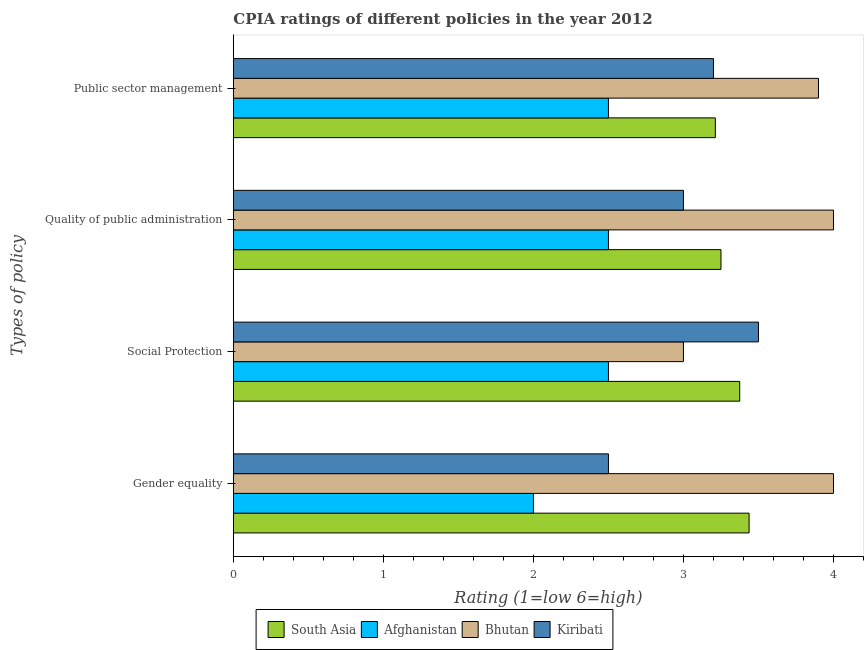How many different coloured bars are there?
Provide a succinct answer. 4. How many groups of bars are there?
Give a very brief answer. 4. Are the number of bars per tick equal to the number of legend labels?
Your answer should be very brief. Yes. Are the number of bars on each tick of the Y-axis equal?
Your response must be concise. Yes. How many bars are there on the 1st tick from the top?
Your answer should be very brief. 4. How many bars are there on the 3rd tick from the bottom?
Offer a very short reply. 4. What is the label of the 3rd group of bars from the top?
Make the answer very short. Social Protection. In which country was the cpia rating of public sector management maximum?
Offer a terse response. Bhutan. In which country was the cpia rating of quality of public administration minimum?
Give a very brief answer. Afghanistan. What is the total cpia rating of public sector management in the graph?
Make the answer very short. 12.81. What is the difference between the cpia rating of quality of public administration in Afghanistan and that in South Asia?
Your response must be concise. -0.75. What is the difference between the cpia rating of public sector management in South Asia and the cpia rating of gender equality in Kiribati?
Provide a short and direct response. 0.71. What is the average cpia rating of quality of public administration per country?
Offer a terse response. 3.19. What is the difference between the cpia rating of public sector management and cpia rating of social protection in South Asia?
Keep it short and to the point. -0.16. In how many countries, is the cpia rating of social protection greater than 2.6 ?
Keep it short and to the point. 3. What is the ratio of the cpia rating of public sector management in Afghanistan to that in South Asia?
Ensure brevity in your answer.  0.78. Is the difference between the cpia rating of social protection in Bhutan and Afghanistan greater than the difference between the cpia rating of quality of public administration in Bhutan and Afghanistan?
Offer a terse response. No. What is the difference between the highest and the second highest cpia rating of public sector management?
Your answer should be very brief. 0.69. What is the difference between the highest and the lowest cpia rating of quality of public administration?
Your answer should be compact. 1.5. Is the sum of the cpia rating of social protection in South Asia and Afghanistan greater than the maximum cpia rating of gender equality across all countries?
Offer a terse response. Yes. What does the 3rd bar from the top in Quality of public administration represents?
Give a very brief answer. Afghanistan. What does the 1st bar from the bottom in Social Protection represents?
Offer a terse response. South Asia. Is it the case that in every country, the sum of the cpia rating of gender equality and cpia rating of social protection is greater than the cpia rating of quality of public administration?
Your answer should be compact. Yes. How many countries are there in the graph?
Offer a terse response. 4. What is the difference between two consecutive major ticks on the X-axis?
Give a very brief answer. 1. Are the values on the major ticks of X-axis written in scientific E-notation?
Make the answer very short. No. Does the graph contain any zero values?
Give a very brief answer. No. How are the legend labels stacked?
Keep it short and to the point. Horizontal. What is the title of the graph?
Your answer should be very brief. CPIA ratings of different policies in the year 2012. What is the label or title of the X-axis?
Keep it short and to the point. Rating (1=low 6=high). What is the label or title of the Y-axis?
Ensure brevity in your answer.  Types of policy. What is the Rating (1=low 6=high) in South Asia in Gender equality?
Your answer should be compact. 3.44. What is the Rating (1=low 6=high) in Afghanistan in Gender equality?
Make the answer very short. 2. What is the Rating (1=low 6=high) in South Asia in Social Protection?
Offer a terse response. 3.38. What is the Rating (1=low 6=high) in Afghanistan in Social Protection?
Make the answer very short. 2.5. What is the Rating (1=low 6=high) of Bhutan in Social Protection?
Your response must be concise. 3. What is the Rating (1=low 6=high) of South Asia in Quality of public administration?
Keep it short and to the point. 3.25. What is the Rating (1=low 6=high) in Bhutan in Quality of public administration?
Your answer should be compact. 4. What is the Rating (1=low 6=high) of South Asia in Public sector management?
Your answer should be compact. 3.21. What is the Rating (1=low 6=high) in Kiribati in Public sector management?
Keep it short and to the point. 3.2. Across all Types of policy, what is the maximum Rating (1=low 6=high) of South Asia?
Your response must be concise. 3.44. Across all Types of policy, what is the maximum Rating (1=low 6=high) in Kiribati?
Give a very brief answer. 3.5. Across all Types of policy, what is the minimum Rating (1=low 6=high) in South Asia?
Make the answer very short. 3.21. What is the total Rating (1=low 6=high) in South Asia in the graph?
Provide a succinct answer. 13.28. What is the total Rating (1=low 6=high) of Kiribati in the graph?
Your answer should be very brief. 12.2. What is the difference between the Rating (1=low 6=high) in South Asia in Gender equality and that in Social Protection?
Offer a terse response. 0.06. What is the difference between the Rating (1=low 6=high) in Afghanistan in Gender equality and that in Social Protection?
Your response must be concise. -0.5. What is the difference between the Rating (1=low 6=high) in Bhutan in Gender equality and that in Social Protection?
Provide a succinct answer. 1. What is the difference between the Rating (1=low 6=high) in South Asia in Gender equality and that in Quality of public administration?
Your answer should be compact. 0.19. What is the difference between the Rating (1=low 6=high) of South Asia in Gender equality and that in Public sector management?
Keep it short and to the point. 0.23. What is the difference between the Rating (1=low 6=high) of South Asia in Social Protection and that in Quality of public administration?
Ensure brevity in your answer.  0.12. What is the difference between the Rating (1=low 6=high) of South Asia in Social Protection and that in Public sector management?
Provide a short and direct response. 0.16. What is the difference between the Rating (1=low 6=high) of Afghanistan in Social Protection and that in Public sector management?
Give a very brief answer. 0. What is the difference between the Rating (1=low 6=high) in Bhutan in Social Protection and that in Public sector management?
Offer a terse response. -0.9. What is the difference between the Rating (1=low 6=high) of Kiribati in Social Protection and that in Public sector management?
Offer a very short reply. 0.3. What is the difference between the Rating (1=low 6=high) of South Asia in Quality of public administration and that in Public sector management?
Offer a terse response. 0.04. What is the difference between the Rating (1=low 6=high) in Bhutan in Quality of public administration and that in Public sector management?
Ensure brevity in your answer.  0.1. What is the difference between the Rating (1=low 6=high) in Kiribati in Quality of public administration and that in Public sector management?
Ensure brevity in your answer.  -0.2. What is the difference between the Rating (1=low 6=high) of South Asia in Gender equality and the Rating (1=low 6=high) of Bhutan in Social Protection?
Offer a terse response. 0.44. What is the difference between the Rating (1=low 6=high) in South Asia in Gender equality and the Rating (1=low 6=high) in Kiribati in Social Protection?
Your response must be concise. -0.06. What is the difference between the Rating (1=low 6=high) in South Asia in Gender equality and the Rating (1=low 6=high) in Bhutan in Quality of public administration?
Provide a succinct answer. -0.56. What is the difference between the Rating (1=low 6=high) of South Asia in Gender equality and the Rating (1=low 6=high) of Kiribati in Quality of public administration?
Provide a succinct answer. 0.44. What is the difference between the Rating (1=low 6=high) in Afghanistan in Gender equality and the Rating (1=low 6=high) in Kiribati in Quality of public administration?
Ensure brevity in your answer.  -1. What is the difference between the Rating (1=low 6=high) of Bhutan in Gender equality and the Rating (1=low 6=high) of Kiribati in Quality of public administration?
Offer a terse response. 1. What is the difference between the Rating (1=low 6=high) in South Asia in Gender equality and the Rating (1=low 6=high) in Bhutan in Public sector management?
Your answer should be compact. -0.46. What is the difference between the Rating (1=low 6=high) of South Asia in Gender equality and the Rating (1=low 6=high) of Kiribati in Public sector management?
Keep it short and to the point. 0.24. What is the difference between the Rating (1=low 6=high) in Afghanistan in Gender equality and the Rating (1=low 6=high) in Kiribati in Public sector management?
Provide a short and direct response. -1.2. What is the difference between the Rating (1=low 6=high) of Bhutan in Gender equality and the Rating (1=low 6=high) of Kiribati in Public sector management?
Provide a short and direct response. 0.8. What is the difference between the Rating (1=low 6=high) of South Asia in Social Protection and the Rating (1=low 6=high) of Bhutan in Quality of public administration?
Offer a terse response. -0.62. What is the difference between the Rating (1=low 6=high) of Afghanistan in Social Protection and the Rating (1=low 6=high) of Bhutan in Quality of public administration?
Your response must be concise. -1.5. What is the difference between the Rating (1=low 6=high) in South Asia in Social Protection and the Rating (1=low 6=high) in Bhutan in Public sector management?
Provide a short and direct response. -0.53. What is the difference between the Rating (1=low 6=high) of South Asia in Social Protection and the Rating (1=low 6=high) of Kiribati in Public sector management?
Your answer should be very brief. 0.17. What is the difference between the Rating (1=low 6=high) in Afghanistan in Social Protection and the Rating (1=low 6=high) in Bhutan in Public sector management?
Your response must be concise. -1.4. What is the difference between the Rating (1=low 6=high) of Afghanistan in Social Protection and the Rating (1=low 6=high) of Kiribati in Public sector management?
Provide a succinct answer. -0.7. What is the difference between the Rating (1=low 6=high) of Bhutan in Social Protection and the Rating (1=low 6=high) of Kiribati in Public sector management?
Your response must be concise. -0.2. What is the difference between the Rating (1=low 6=high) in South Asia in Quality of public administration and the Rating (1=low 6=high) in Afghanistan in Public sector management?
Your answer should be compact. 0.75. What is the difference between the Rating (1=low 6=high) in South Asia in Quality of public administration and the Rating (1=low 6=high) in Bhutan in Public sector management?
Your response must be concise. -0.65. What is the difference between the Rating (1=low 6=high) in South Asia in Quality of public administration and the Rating (1=low 6=high) in Kiribati in Public sector management?
Give a very brief answer. 0.05. What is the average Rating (1=low 6=high) in South Asia per Types of policy?
Provide a short and direct response. 3.32. What is the average Rating (1=low 6=high) in Afghanistan per Types of policy?
Give a very brief answer. 2.38. What is the average Rating (1=low 6=high) in Bhutan per Types of policy?
Ensure brevity in your answer.  3.73. What is the average Rating (1=low 6=high) of Kiribati per Types of policy?
Keep it short and to the point. 3.05. What is the difference between the Rating (1=low 6=high) of South Asia and Rating (1=low 6=high) of Afghanistan in Gender equality?
Your response must be concise. 1.44. What is the difference between the Rating (1=low 6=high) in South Asia and Rating (1=low 6=high) in Bhutan in Gender equality?
Keep it short and to the point. -0.56. What is the difference between the Rating (1=low 6=high) in South Asia and Rating (1=low 6=high) in Kiribati in Gender equality?
Offer a terse response. 0.94. What is the difference between the Rating (1=low 6=high) of Afghanistan and Rating (1=low 6=high) of Bhutan in Gender equality?
Ensure brevity in your answer.  -2. What is the difference between the Rating (1=low 6=high) of Afghanistan and Rating (1=low 6=high) of Kiribati in Gender equality?
Make the answer very short. -0.5. What is the difference between the Rating (1=low 6=high) in South Asia and Rating (1=low 6=high) in Kiribati in Social Protection?
Your response must be concise. -0.12. What is the difference between the Rating (1=low 6=high) in Afghanistan and Rating (1=low 6=high) in Bhutan in Social Protection?
Make the answer very short. -0.5. What is the difference between the Rating (1=low 6=high) of Bhutan and Rating (1=low 6=high) of Kiribati in Social Protection?
Your answer should be compact. -0.5. What is the difference between the Rating (1=low 6=high) in South Asia and Rating (1=low 6=high) in Afghanistan in Quality of public administration?
Provide a succinct answer. 0.75. What is the difference between the Rating (1=low 6=high) of South Asia and Rating (1=low 6=high) of Bhutan in Quality of public administration?
Provide a succinct answer. -0.75. What is the difference between the Rating (1=low 6=high) in Afghanistan and Rating (1=low 6=high) in Bhutan in Quality of public administration?
Provide a succinct answer. -1.5. What is the difference between the Rating (1=low 6=high) of Afghanistan and Rating (1=low 6=high) of Kiribati in Quality of public administration?
Your answer should be compact. -0.5. What is the difference between the Rating (1=low 6=high) of Bhutan and Rating (1=low 6=high) of Kiribati in Quality of public administration?
Make the answer very short. 1. What is the difference between the Rating (1=low 6=high) of South Asia and Rating (1=low 6=high) of Afghanistan in Public sector management?
Provide a short and direct response. 0.71. What is the difference between the Rating (1=low 6=high) in South Asia and Rating (1=low 6=high) in Bhutan in Public sector management?
Make the answer very short. -0.69. What is the difference between the Rating (1=low 6=high) of South Asia and Rating (1=low 6=high) of Kiribati in Public sector management?
Provide a short and direct response. 0.01. What is the ratio of the Rating (1=low 6=high) of South Asia in Gender equality to that in Social Protection?
Give a very brief answer. 1.02. What is the ratio of the Rating (1=low 6=high) of Bhutan in Gender equality to that in Social Protection?
Offer a terse response. 1.33. What is the ratio of the Rating (1=low 6=high) in South Asia in Gender equality to that in Quality of public administration?
Make the answer very short. 1.06. What is the ratio of the Rating (1=low 6=high) in South Asia in Gender equality to that in Public sector management?
Give a very brief answer. 1.07. What is the ratio of the Rating (1=low 6=high) in Afghanistan in Gender equality to that in Public sector management?
Provide a short and direct response. 0.8. What is the ratio of the Rating (1=low 6=high) of Bhutan in Gender equality to that in Public sector management?
Offer a terse response. 1.03. What is the ratio of the Rating (1=low 6=high) of Kiribati in Gender equality to that in Public sector management?
Make the answer very short. 0.78. What is the ratio of the Rating (1=low 6=high) of South Asia in Social Protection to that in Quality of public administration?
Offer a terse response. 1.04. What is the ratio of the Rating (1=low 6=high) in Afghanistan in Social Protection to that in Quality of public administration?
Provide a short and direct response. 1. What is the ratio of the Rating (1=low 6=high) of Kiribati in Social Protection to that in Quality of public administration?
Your response must be concise. 1.17. What is the ratio of the Rating (1=low 6=high) of South Asia in Social Protection to that in Public sector management?
Your answer should be compact. 1.05. What is the ratio of the Rating (1=low 6=high) of Bhutan in Social Protection to that in Public sector management?
Make the answer very short. 0.77. What is the ratio of the Rating (1=low 6=high) of Kiribati in Social Protection to that in Public sector management?
Your response must be concise. 1.09. What is the ratio of the Rating (1=low 6=high) of South Asia in Quality of public administration to that in Public sector management?
Offer a very short reply. 1.01. What is the ratio of the Rating (1=low 6=high) in Bhutan in Quality of public administration to that in Public sector management?
Offer a terse response. 1.03. What is the difference between the highest and the second highest Rating (1=low 6=high) of South Asia?
Your response must be concise. 0.06. What is the difference between the highest and the second highest Rating (1=low 6=high) of Afghanistan?
Ensure brevity in your answer.  0. What is the difference between the highest and the lowest Rating (1=low 6=high) in South Asia?
Your answer should be compact. 0.23. What is the difference between the highest and the lowest Rating (1=low 6=high) of Afghanistan?
Provide a succinct answer. 0.5. What is the difference between the highest and the lowest Rating (1=low 6=high) of Kiribati?
Your answer should be compact. 1. 